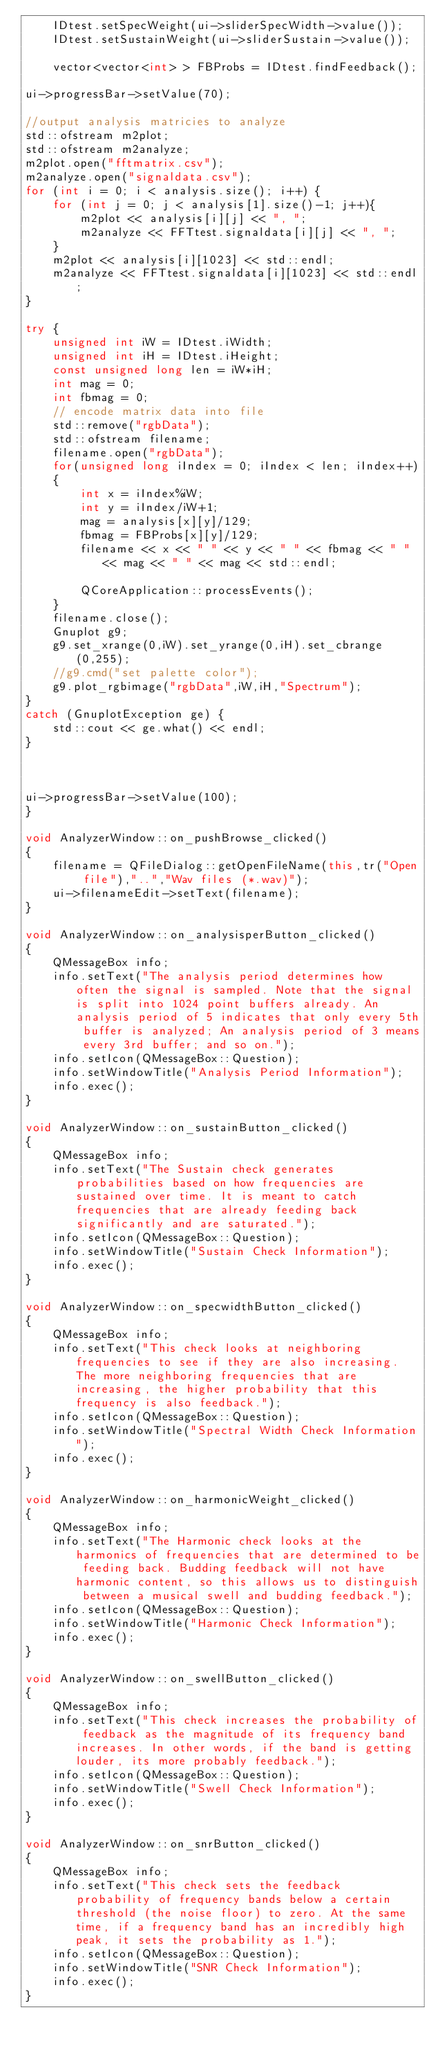<code> <loc_0><loc_0><loc_500><loc_500><_C++_>    IDtest.setSpecWeight(ui->sliderSpecWidth->value());
    IDtest.setSustainWeight(ui->sliderSustain->value());

    vector<vector<int> > FBProbs = IDtest.findFeedback();

ui->progressBar->setValue(70);

//output analysis matricies to analyze
std::ofstream m2plot;
std::ofstream m2analyze;
m2plot.open("fftmatrix.csv");
m2analyze.open("signaldata.csv");
for (int i = 0; i < analysis.size(); i++) {
    for (int j = 0; j < analysis[1].size()-1; j++){
        m2plot << analysis[i][j] << ", ";
        m2analyze << FFTtest.signaldata[i][j] << ", ";
    }
    m2plot << analysis[i][1023] << std::endl;
    m2analyze << FFTtest.signaldata[i][1023] << std::endl;
}

try {
    unsigned int iW = IDtest.iWidth;
    unsigned int iH = IDtest.iHeight;
    const unsigned long len = iW*iH;
    int mag = 0;
    int fbmag = 0;
    // encode matrix data into file
    std::remove("rgbData");
    std::ofstream filename;
    filename.open("rgbData");
    for(unsigned long iIndex = 0; iIndex < len; iIndex++)
    {
        int x = iIndex%iW;
        int y = iIndex/iW+1;
        mag = analysis[x][y]/129;
        fbmag = FBProbs[x][y]/129;
        filename << x << " " << y << " " << fbmag << " " << mag << " " << mag << std::endl;

        QCoreApplication::processEvents();
    }
    filename.close();
    Gnuplot g9;
    g9.set_xrange(0,iW).set_yrange(0,iH).set_cbrange(0,255);
    //g9.cmd("set palette color");
    g9.plot_rgbimage("rgbData",iW,iH,"Spectrum");
}
catch (GnuplotException ge) {
    std::cout << ge.what() << endl;
}



ui->progressBar->setValue(100);
}

void AnalyzerWindow::on_pushBrowse_clicked()
{
    filename = QFileDialog::getOpenFileName(this,tr("Open file"),"..","Wav files (*.wav)");
    ui->filenameEdit->setText(filename);
}

void AnalyzerWindow::on_analysisperButton_clicked()
{
    QMessageBox info;
    info.setText("The analysis period determines how often the signal is sampled. Note that the signal is split into 1024 point buffers already. An analysis period of 5 indicates that only every 5th buffer is analyzed; An analysis period of 3 means every 3rd buffer; and so on.");
    info.setIcon(QMessageBox::Question);
    info.setWindowTitle("Analysis Period Information");
    info.exec();
}

void AnalyzerWindow::on_sustainButton_clicked()
{
    QMessageBox info;
    info.setText("The Sustain check generates probabilities based on how frequencies are sustained over time. It is meant to catch frequencies that are already feeding back significantly and are saturated.");
    info.setIcon(QMessageBox::Question);
    info.setWindowTitle("Sustain Check Information");
    info.exec();
}

void AnalyzerWindow::on_specwidthButton_clicked()
{
    QMessageBox info;
    info.setText("This check looks at neighboring frequencies to see if they are also increasing. The more neighboring frequencies that are increasing, the higher probability that this frequency is also feedback.");
    info.setIcon(QMessageBox::Question);
    info.setWindowTitle("Spectral Width Check Information");
    info.exec();
}

void AnalyzerWindow::on_harmonicWeight_clicked()
{
    QMessageBox info;
    info.setText("The Harmonic check looks at the harmonics of frequencies that are determined to be feeding back. Budding feedback will not have harmonic content, so this allows us to distinguish between a musical swell and budding feedback.");
    info.setIcon(QMessageBox::Question);
    info.setWindowTitle("Harmonic Check Information");
    info.exec();
}

void AnalyzerWindow::on_swellButton_clicked()
{
    QMessageBox info;
    info.setText("This check increases the probability of feedback as the magnitude of its frequency band increases. In other words, if the band is getting louder, its more probably feedback.");
    info.setIcon(QMessageBox::Question);
    info.setWindowTitle("Swell Check Information");
    info.exec();
}

void AnalyzerWindow::on_snrButton_clicked()
{
    QMessageBox info;
    info.setText("This check sets the feedback probability of frequency bands below a certain threshold (the noise floor) to zero. At the same time, if a frequency band has an incredibly high peak, it sets the probability as 1.");
    info.setIcon(QMessageBox::Question);
    info.setWindowTitle("SNR Check Information");
    info.exec();
}
</code> 